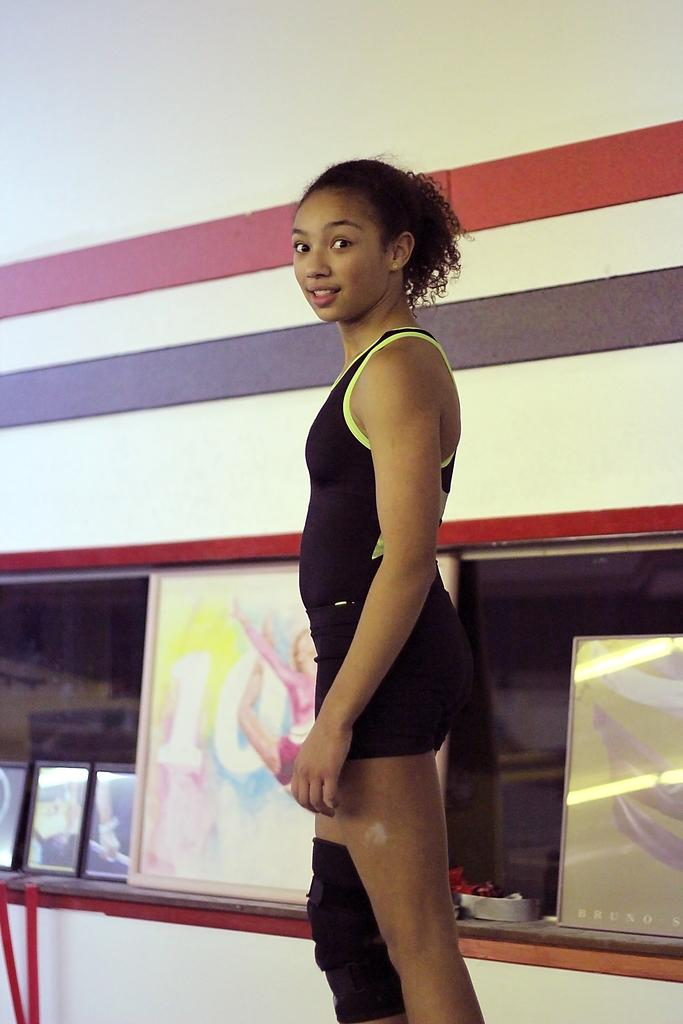Who is present in the image? There is a woman in the image. What is the woman wearing? The woman is wearing a black dress. What expression does the woman have? The woman is smiling. What can be seen in the background of the image? There are photo frames and a white color wall in the background of the image. What type of pencil is the woman using to draw in the image? There is no pencil present in the image, and the woman is not drawing. 